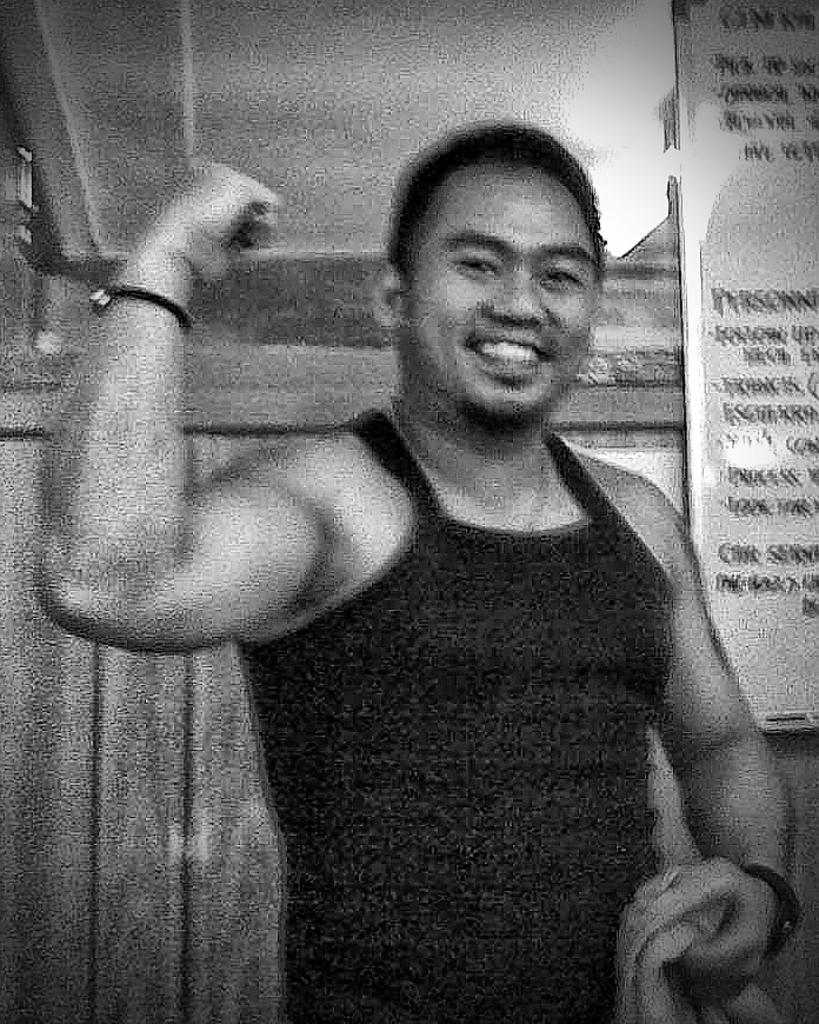What can be seen in the image? There is a person in the image. What is the person holding? The person is holding a towel. What else is present in the image besides the person? There is a display board with text in the image. What is behind the display board? There is a wall behind the display board. What is the person's opinion about butter in the image? There is no indication of the person's opinion about butter in the image. 